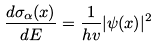Convert formula to latex. <formula><loc_0><loc_0><loc_500><loc_500>\frac { d \sigma _ { \alpha } ( x ) } { d E } = \frac { 1 } { h v } | \psi ( x ) | ^ { 2 }</formula> 